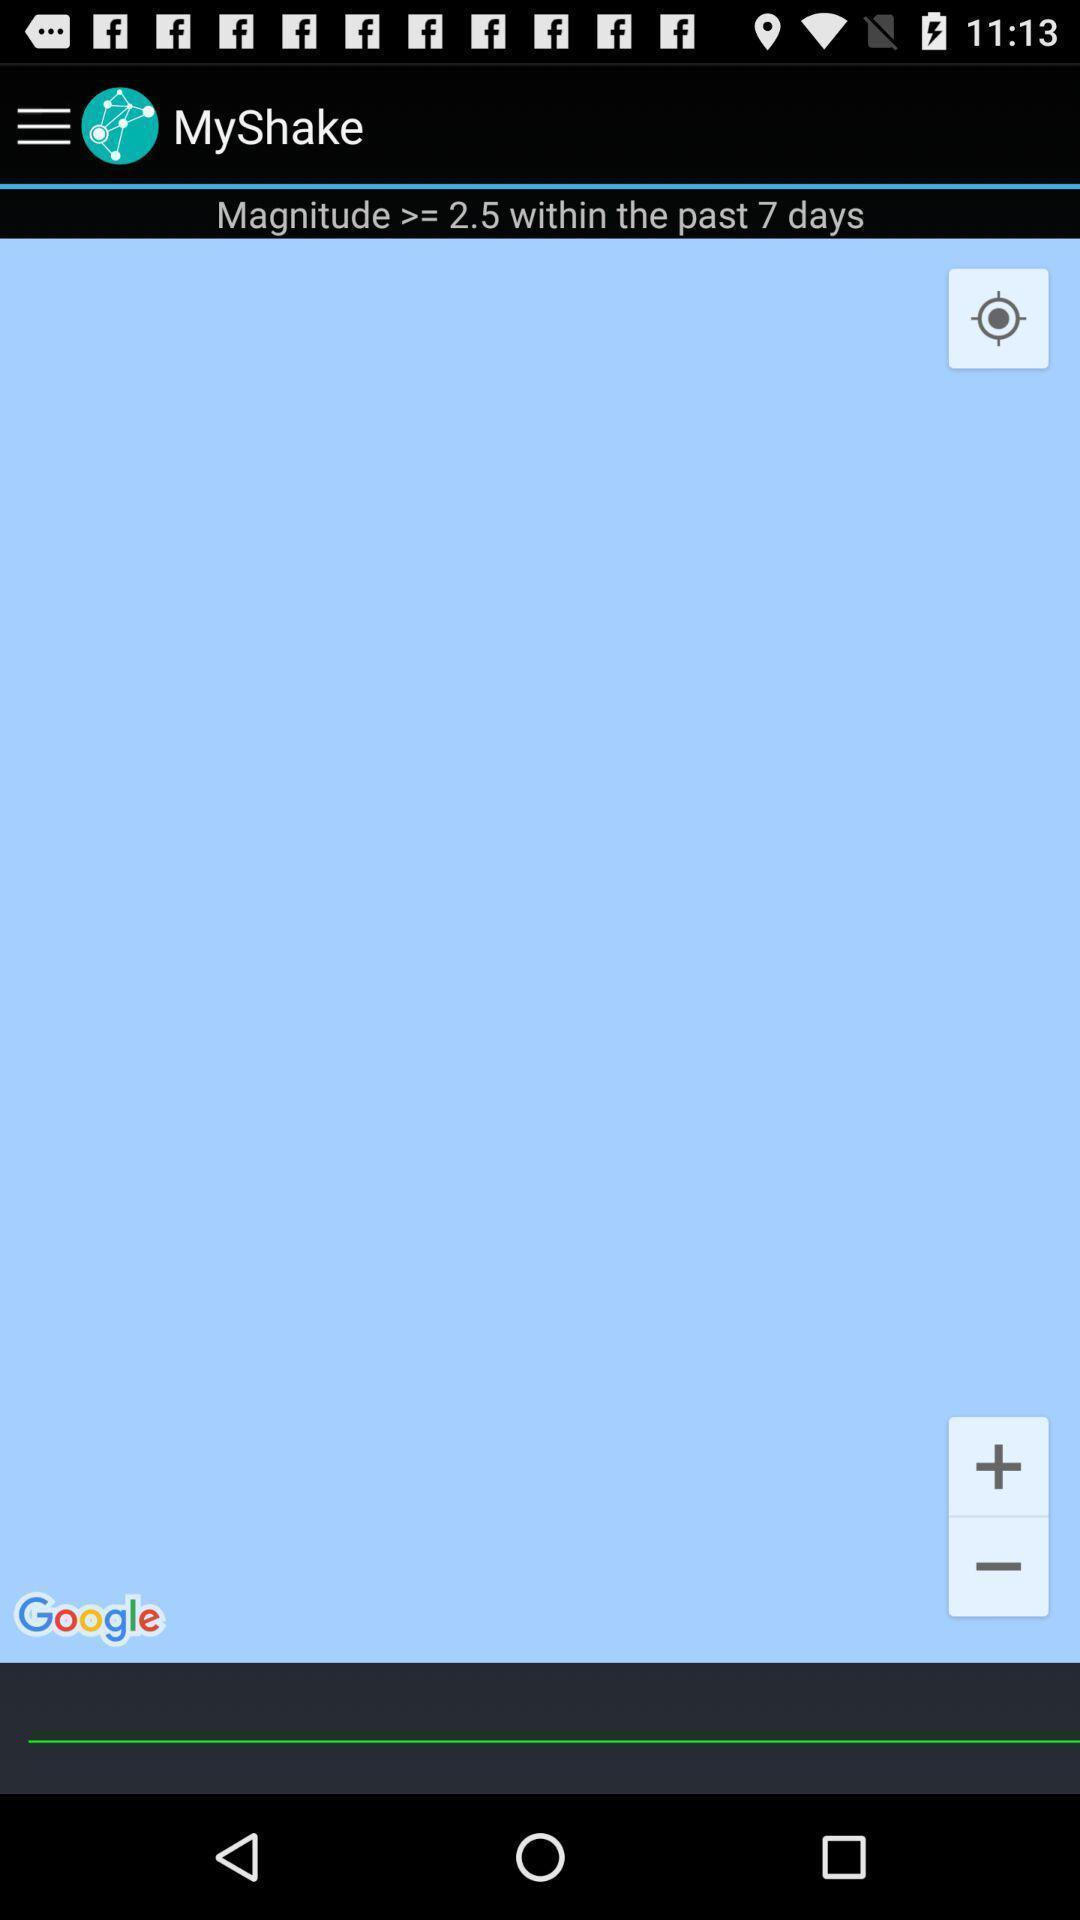Tell me what you see in this picture. Page showing location type options. 